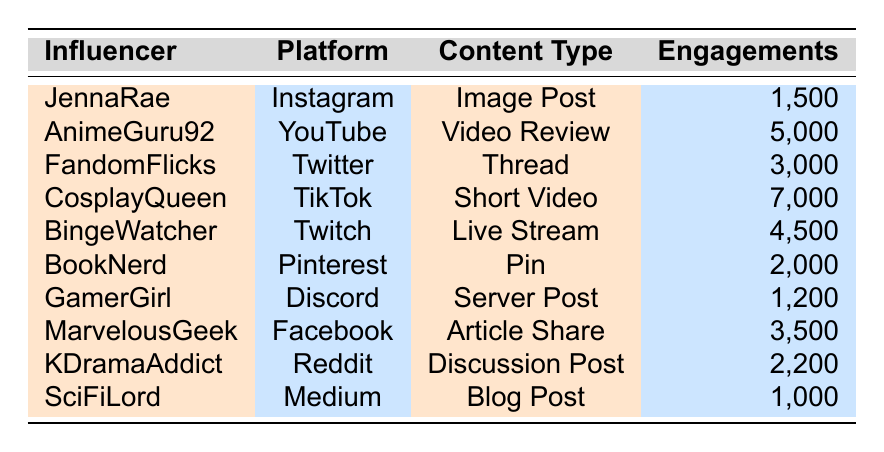What is the highest engagement among fan influencers listed in the table? Looking at the Engagements column, CosplayQueen has the highest number at 7,000.
Answer: 7,000 Which influencer has the lowest engagements in their content type? The lowest number of engagements is listed for SciFiLord with 1,000.
Answer: 1,000 How many different content types are represented by the influencers in the table? The content types represented are: Image Post, Video Review, Thread, Short Video, Live Stream, Pin, Server Post, Article Share, Discussion Post, and Blog Post, totaling 10 different types.
Answer: 10 What type of content does AnimeGuru92 share? According to the table, AnimeGuru92 shares a Video Review.
Answer: Video Review Calculate the total engagements for all influencers combined. Adding the engagements gives: 1,500 + 5,000 + 3,000 + 7,000 + 4,500 + 2,000 + 1,200 + 3,500 + 2,200 + 1,000 = 30,900.
Answer: 30,900 Does FandomFlicks have more engagements than MarvelousGeek? FandomFlicks has 3,000 engagements, while MarvelousGeek has 3,500, so the statement is false.
Answer: No Which platform has the influencer with the highest engagements, and what is the engagement amount? CosplayQueen on TikTok has the highest engagements at 7,000.
Answer: TikTok, 7,000 How many influencers create video content in this table? The influencers creating video content are AnimeGuru92 (Video Review) and CosplayQueen (Short Video), totaling 2.
Answer: 2 Is there any influencer whose content is focused on text-based engagement? Yes, both BookNerd (Pin) and SciFiLord (Blog Post) focus on text-based content.
Answer: Yes What is the average number of engagements across all influencers? The total engagements calculated previously is 30,900 and there are 10 influencers. Therefore, the average is 30,900 / 10 = 3,090.
Answer: 3,090 Which influencer gets the most likes on their content? CosplayQueen gets the most likes with a total of 6,000.
Answer: 6,000 